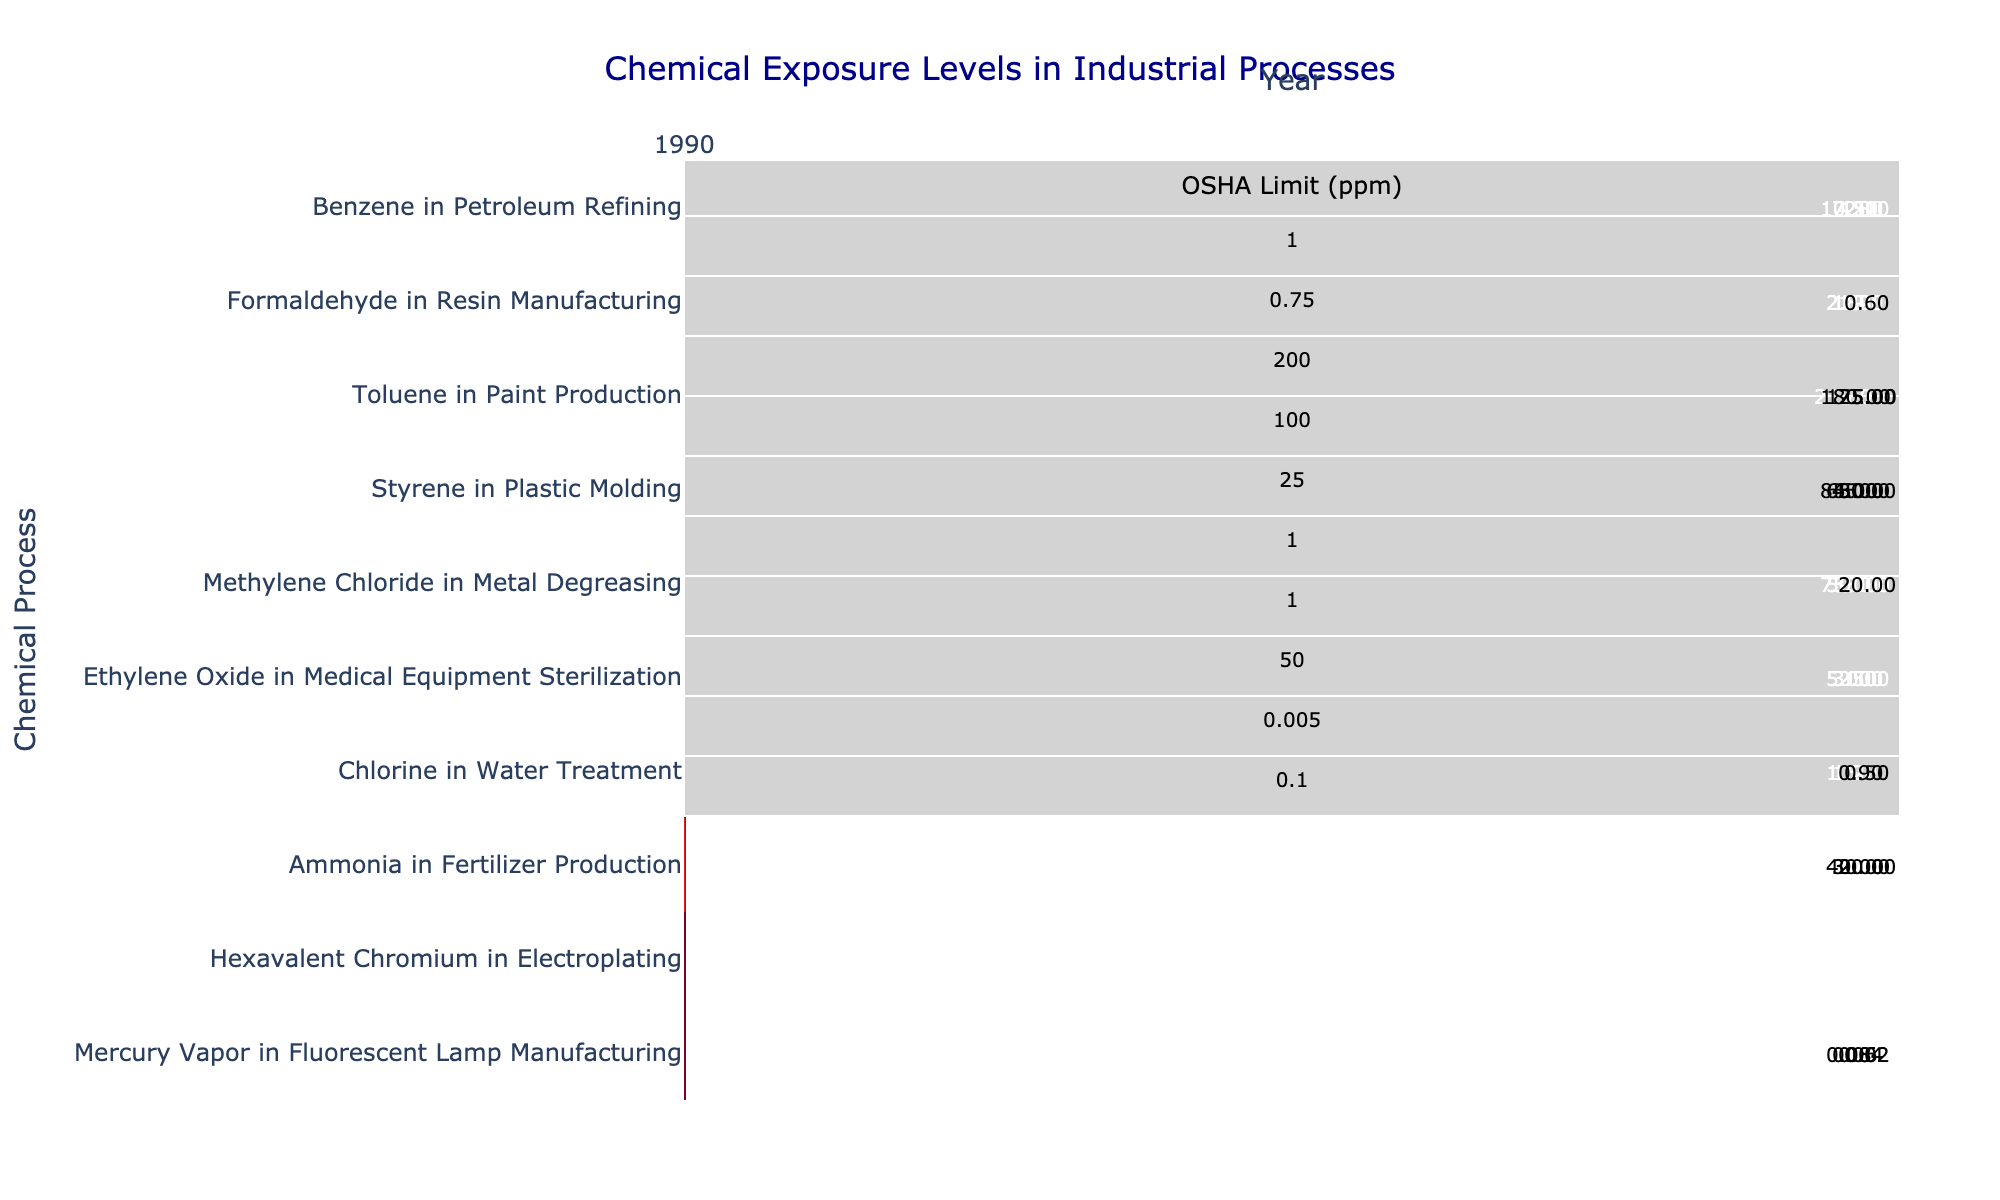What is the exposure level of Benzene in Petroleum Refining in 2010? The table shows that Benzene in Petroleum Refining had an exposure level of 4.8 ppm in 2010.
Answer: 4.8 ppm Is the formaldehyde exposure level in 2020 above the OSHA limit? The table indicates that the formaldehyde exposure level in 2020 is 0.6 ppm, while the OSHA limit is 0.75 ppm. Since 0.6 is below 0.75, it is not above the limit.
Answer: No What was the change in exposure level for Toluene in Paint Production from 1990 to 2020? In 1990, Toluene had an exposure level of 215.0 ppm, and in 2020 it decreased to 75.0 ppm. The change is calculated as 215.0 - 75.0 = 140.0 ppm decrease.
Answer: 140.0 ppm decrease Which chemical process had the highest exposure level in 1990? The table lists the exposure levels for various chemicals in 1990. For that year, Toluene in Paint Production had the highest level at 215.0 ppm.
Answer: Toluene in Paint Production What is the average exposure level of Methylene Chloride in the years provided? The exposure levels for Methylene Chloride are 75.0 ppm (1990), 50.0 ppm (2000), 35.0 ppm (2010), and 20.0 ppm (2020). Adding these gives 75 + 50 + 35 + 20 = 180, and dividing by 4 gives an average of 180/4 = 45.0 ppm.
Answer: 45.0 ppm Is there a chemical process that exceeded its OSHA limit in any year, and if yes, which one? Looking at the data, Toluene in Paint Production in 1990 (215.0 ppm) exceeds its OSHA limit of 200.0 ppm. Other years for Toluene and other chemicals do not exceed their limits.
Answer: Yes, Toluene in Paint Production in 1990 What was the lowest exposure level recorded for Hexavalent Chromium between 1990 and 2020? The exposure levels for Hexavalent Chromium were 0.1 ppm (1990), 0.075 ppm (2000), 0.05 ppm (2010), and 0.025 ppm (2020). The lowest of these is 0.025 ppm in 2020.
Answer: 0.025 ppm Which chemical had the largest decrease in exposure levels from 1990 to 2020? To find the largest decrease, we compare changes: Benzene decreased by 8.4 ppm, Formaldehyde by 2.2 ppm, Toluene by 140.0 ppm, Styrene by 55.0 ppm, Methylene Chloride by 55.0 ppm, Ethylene Oxide by 4.0 ppm, Chlorine by 1.0 ppm, Ammonia by 35.0 ppm, Hexavalent Chromium by 0.075 ppm, and Mercury Vapor by 0.06 ppm. Toluene has the largest decrease of 140.0 ppm.
Answer: Toluene in Paint Production How does the exposure level of Ammonia in 2020 compare to its OSHA limit? The exposure level for Ammonia in 2020 is 20.0 ppm, whereas the OSHA limit is 50.0 ppm. Since 20.0 is less than 50.0, it is below the limit.
Answer: Below the limit What is the trend in exposure levels for Chlorine over the years? Starting from 1.5 ppm in 1990, Chlorine levels decreased to 1.2 ppm in 2000, then to 0.9 ppm in 2010, and finally to 0.5 ppm in 2020, showing a decreasing trend over the years.
Answer: Decreasing trend Which years had exposure levels for Methylene Chloride that were below its OSHA limit? Methylene Chloride recorded 75.0 ppm in 1990 and 50.0 ppm in 2000, both above the OSHA limit of 25.0 ppm. In 2010, it was 35.0 ppm, above the limit. However, in 2020, it dropped to 20.0 ppm, which is below the OSHA limit. Thus, only 2020 was below the limit.
Answer: 2020 